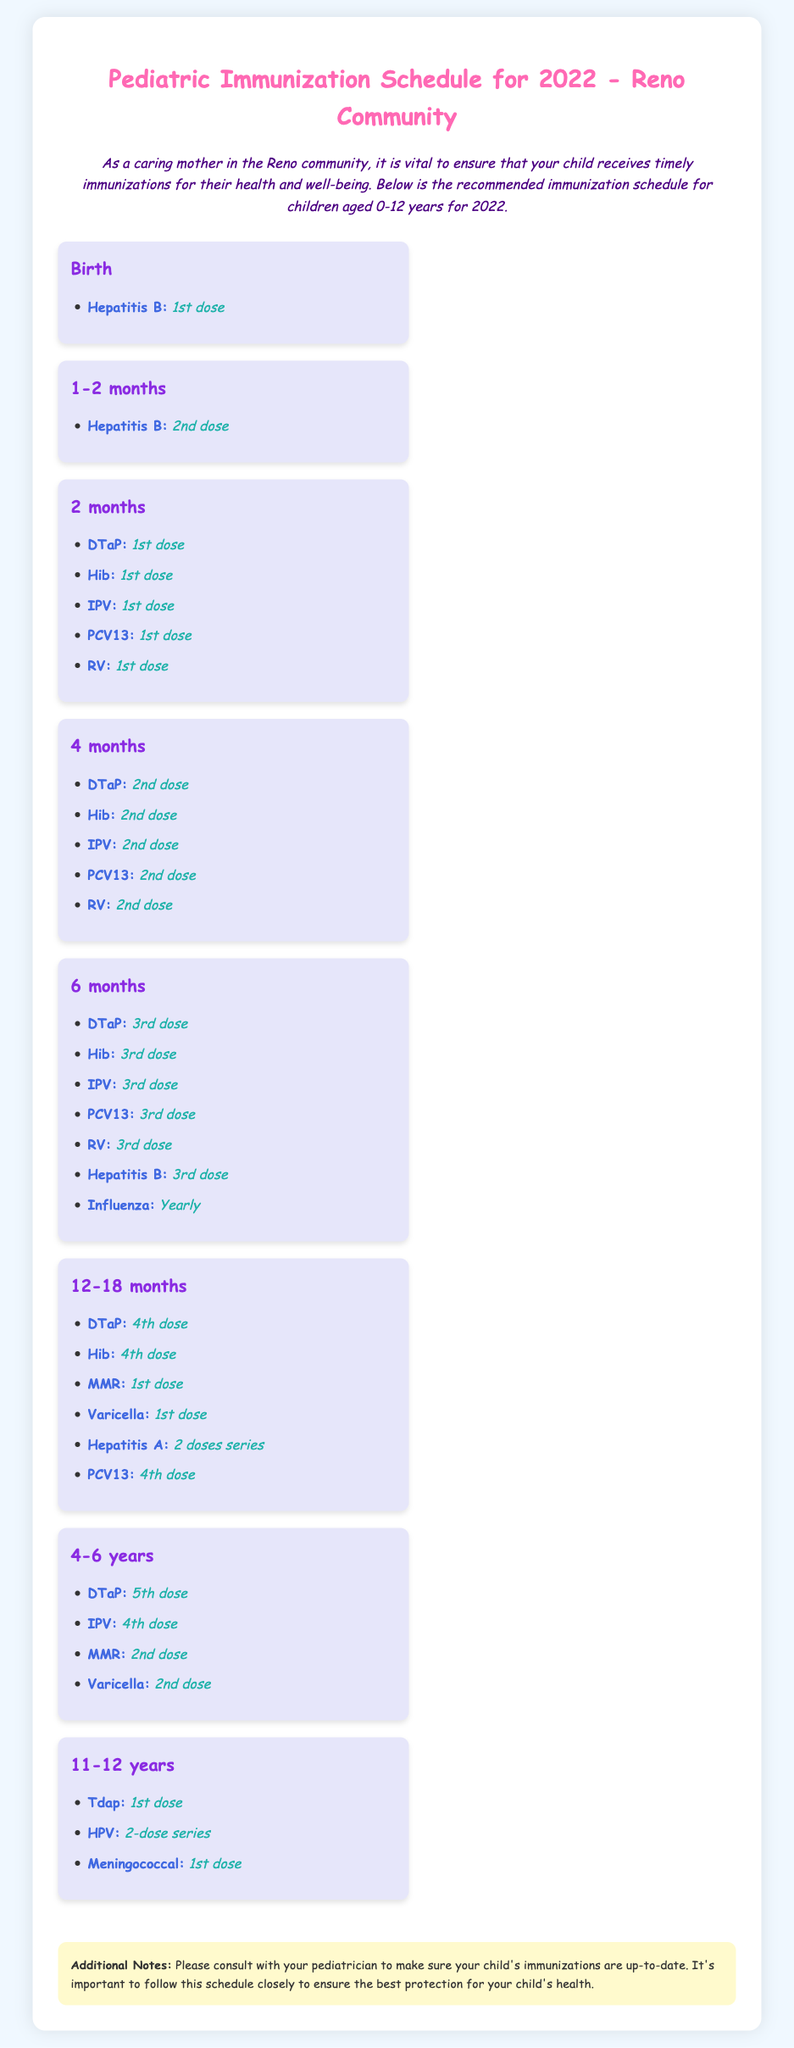What is the first vaccine given at birth? The first vaccine listed for newborns is Hepatitis B, which is administered as the 1st dose right after birth.
Answer: Hepatitis B At what age is the DTaP vaccine first given? According to the schedule, the DTaP vaccine is first administered at 2 months of age as the 1st dose.
Answer: 2 months How many doses of the Hepatitis A vaccine are required? The document states that the Hepatitis A vaccine is given in a 2 doses series for children aged 12-18 months.
Answer: 2 doses series Which vaccines are required at 4-6 years? The vaccines listed for the 4-6 years age group include DTaP, IPV, MMR, and Varicella.
Answer: DTaP, IPV, MMR, Varicella What is the minimum age for receiving the HPV vaccine? The HPV vaccine is first given to children aged 11-12 years, as indicated in the schedule.
Answer: 11-12 years What immunization is done yearly starting at 6 months? The document specifies that the Influenza vaccine is given yearly starting at 6 months of age.
Answer: Influenza How many doses of the MMR vaccine are required? For children aged 12-18 months and 4-6 years, the MMR vaccine is given as a 1st dose and a 2nd dose.
Answer: 2 doses What is the purpose of consulting with a pediatrician according to the document? The document advises consulting with a pediatrician to ensure that the child's immunizations are up-to-date and follow the schedule closely for the best health protection.
Answer: To ensure immunizations are up-to-date 